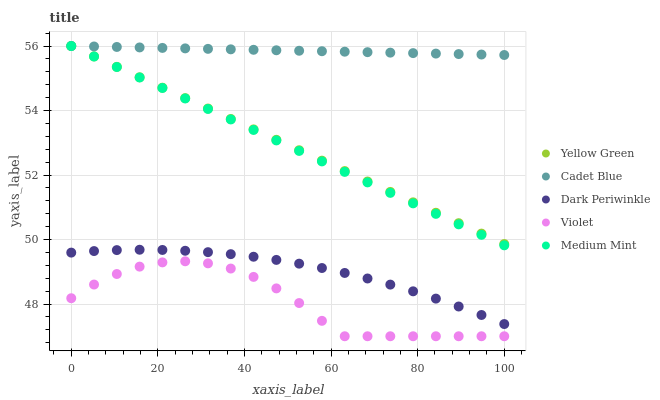Does Violet have the minimum area under the curve?
Answer yes or no. Yes. Does Cadet Blue have the maximum area under the curve?
Answer yes or no. Yes. Does Cadet Blue have the minimum area under the curve?
Answer yes or no. No. Does Violet have the maximum area under the curve?
Answer yes or no. No. Is Yellow Green the smoothest?
Answer yes or no. Yes. Is Violet the roughest?
Answer yes or no. Yes. Is Cadet Blue the smoothest?
Answer yes or no. No. Is Cadet Blue the roughest?
Answer yes or no. No. Does Violet have the lowest value?
Answer yes or no. Yes. Does Cadet Blue have the lowest value?
Answer yes or no. No. Does Yellow Green have the highest value?
Answer yes or no. Yes. Does Violet have the highest value?
Answer yes or no. No. Is Violet less than Cadet Blue?
Answer yes or no. Yes. Is Medium Mint greater than Dark Periwinkle?
Answer yes or no. Yes. Does Yellow Green intersect Medium Mint?
Answer yes or no. Yes. Is Yellow Green less than Medium Mint?
Answer yes or no. No. Is Yellow Green greater than Medium Mint?
Answer yes or no. No. Does Violet intersect Cadet Blue?
Answer yes or no. No. 